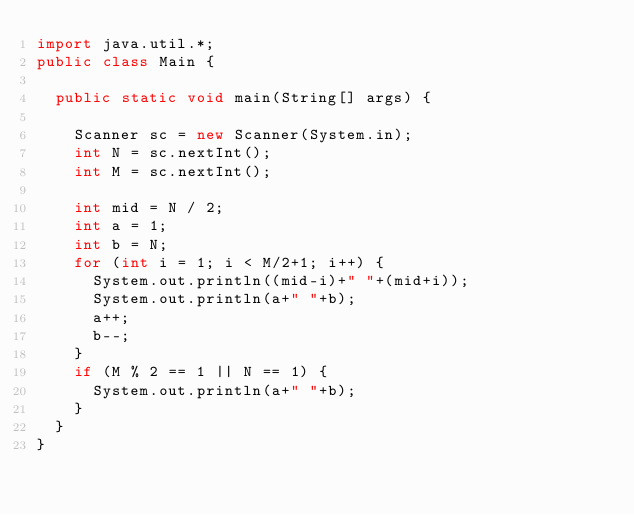<code> <loc_0><loc_0><loc_500><loc_500><_Java_>import java.util.*;
public class Main {

	public static void main(String[] args) {

		Scanner sc = new Scanner(System.in);
		int N = sc.nextInt();
		int M = sc.nextInt();
		
		int mid = N / 2;
		int a = 1;
		int b = N;
		for (int i = 1; i < M/2+1; i++) {
			System.out.println((mid-i)+" "+(mid+i));
			System.out.println(a+" "+b);
			a++;
			b--;
		}
		if (M % 2 == 1 || N == 1) {
			System.out.println(a+" "+b);
		}
	}
}</code> 